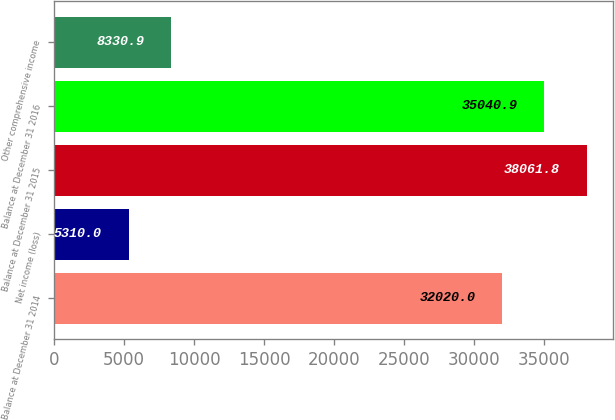<chart> <loc_0><loc_0><loc_500><loc_500><bar_chart><fcel>Balance at December 31 2014<fcel>Net income (loss)<fcel>Balance at December 31 2015<fcel>Balance at December 31 2016<fcel>Other comprehensive income<nl><fcel>32020<fcel>5310<fcel>38061.8<fcel>35040.9<fcel>8330.9<nl></chart> 